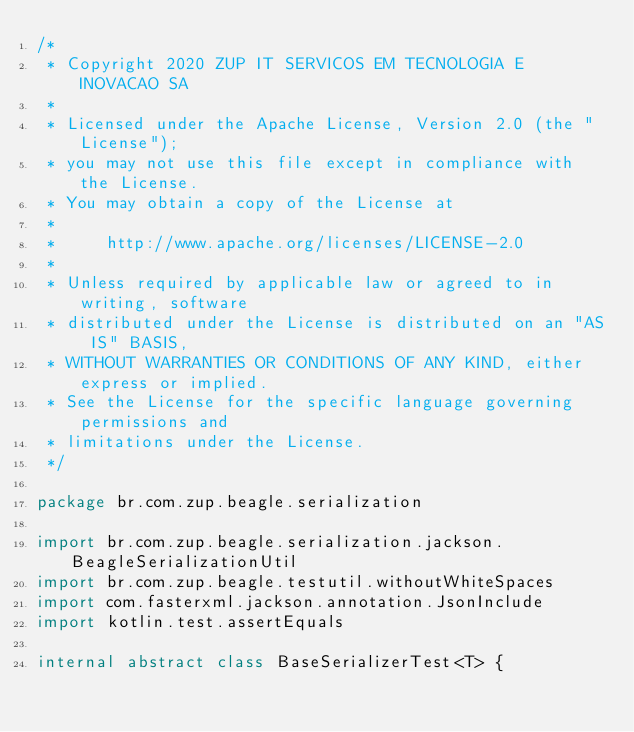Convert code to text. <code><loc_0><loc_0><loc_500><loc_500><_Kotlin_>/*
 * Copyright 2020 ZUP IT SERVICOS EM TECNOLOGIA E INOVACAO SA
 *
 * Licensed under the Apache License, Version 2.0 (the "License");
 * you may not use this file except in compliance with the License.
 * You may obtain a copy of the License at
 *
 *     http://www.apache.org/licenses/LICENSE-2.0
 *
 * Unless required by applicable law or agreed to in writing, software
 * distributed under the License is distributed on an "AS IS" BASIS,
 * WITHOUT WARRANTIES OR CONDITIONS OF ANY KIND, either express or implied.
 * See the License for the specific language governing permissions and
 * limitations under the License.
 */

package br.com.zup.beagle.serialization

import br.com.zup.beagle.serialization.jackson.BeagleSerializationUtil
import br.com.zup.beagle.testutil.withoutWhiteSpaces
import com.fasterxml.jackson.annotation.JsonInclude
import kotlin.test.assertEquals

internal abstract class BaseSerializerTest<T> {
</code> 